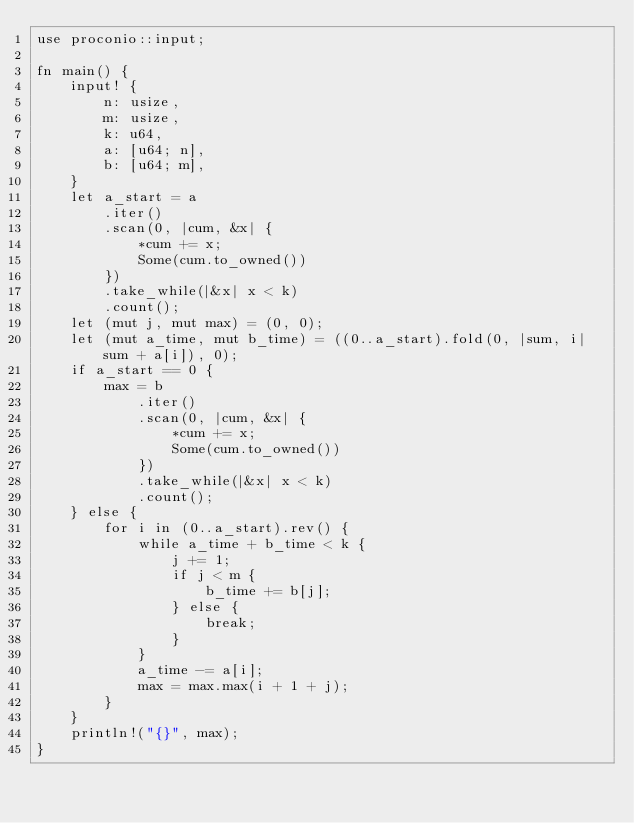Convert code to text. <code><loc_0><loc_0><loc_500><loc_500><_Rust_>use proconio::input;

fn main() {
    input! {
        n: usize,
        m: usize,
        k: u64,
        a: [u64; n],
        b: [u64; m],
    }
    let a_start = a
        .iter()
        .scan(0, |cum, &x| {
            *cum += x;
            Some(cum.to_owned())
        })
        .take_while(|&x| x < k)
        .count();
    let (mut j, mut max) = (0, 0);
    let (mut a_time, mut b_time) = ((0..a_start).fold(0, |sum, i| sum + a[i]), 0);
    if a_start == 0 {
        max = b
            .iter()
            .scan(0, |cum, &x| {
                *cum += x;
                Some(cum.to_owned())
            })
            .take_while(|&x| x < k)
            .count();
    } else {
        for i in (0..a_start).rev() {
            while a_time + b_time < k {
                j += 1;
                if j < m {
                    b_time += b[j];
                } else {
                    break;
                }
            }
            a_time -= a[i];
            max = max.max(i + 1 + j);
        }
    }
    println!("{}", max);
}
</code> 